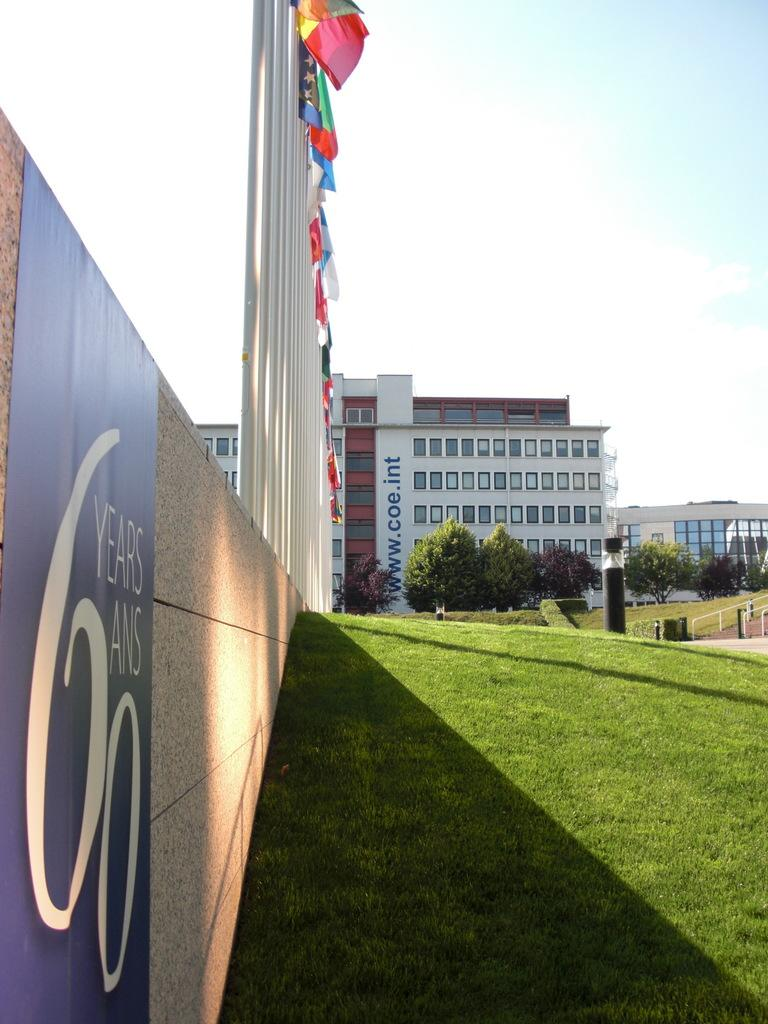<image>
Create a compact narrative representing the image presented. a poster for 60 Years is on the side of an exterior wall 